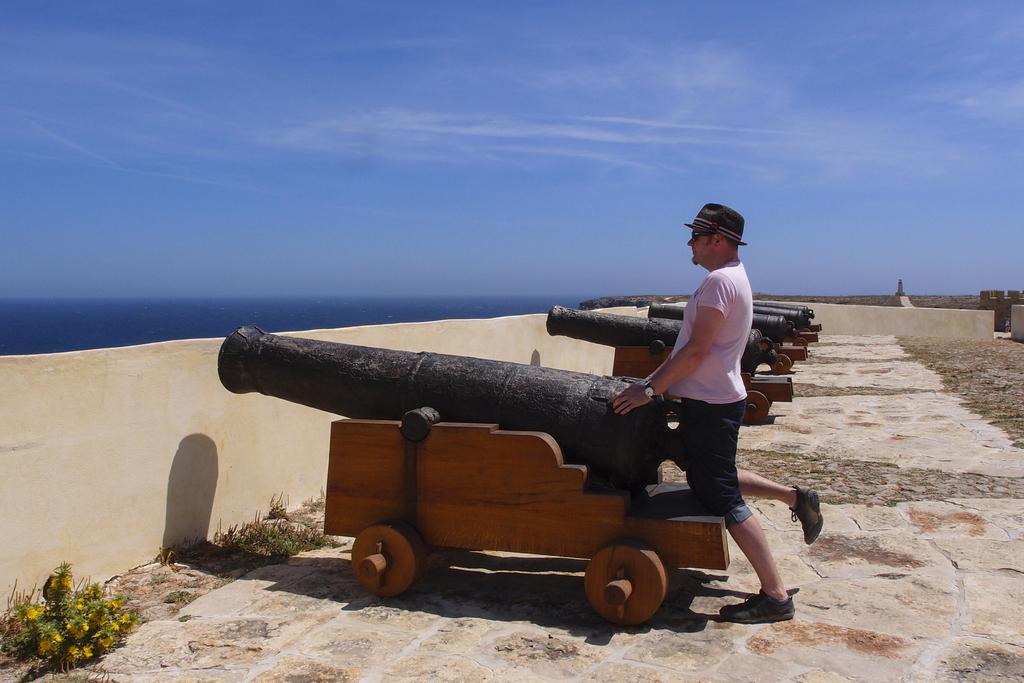What is the main subject of the image? The main subject of the image is a man. What is the man wearing on his upper body? The man is wearing a white T-shirt. What type of headwear is the man wearing? The man is wearing a black hat. What type of surface is visible beneath the man? There is a floor visible in the image. What is on the left side of the image? There is a wall on the left side of the image. What is visible at the top of the image? The sky is visible at the top of the image. How many books can be seen on the man's can in the image? There is no can or books present in the image. What type of team is the man a part of in the image? There is no indication of a team or any team-related activity in the image. 